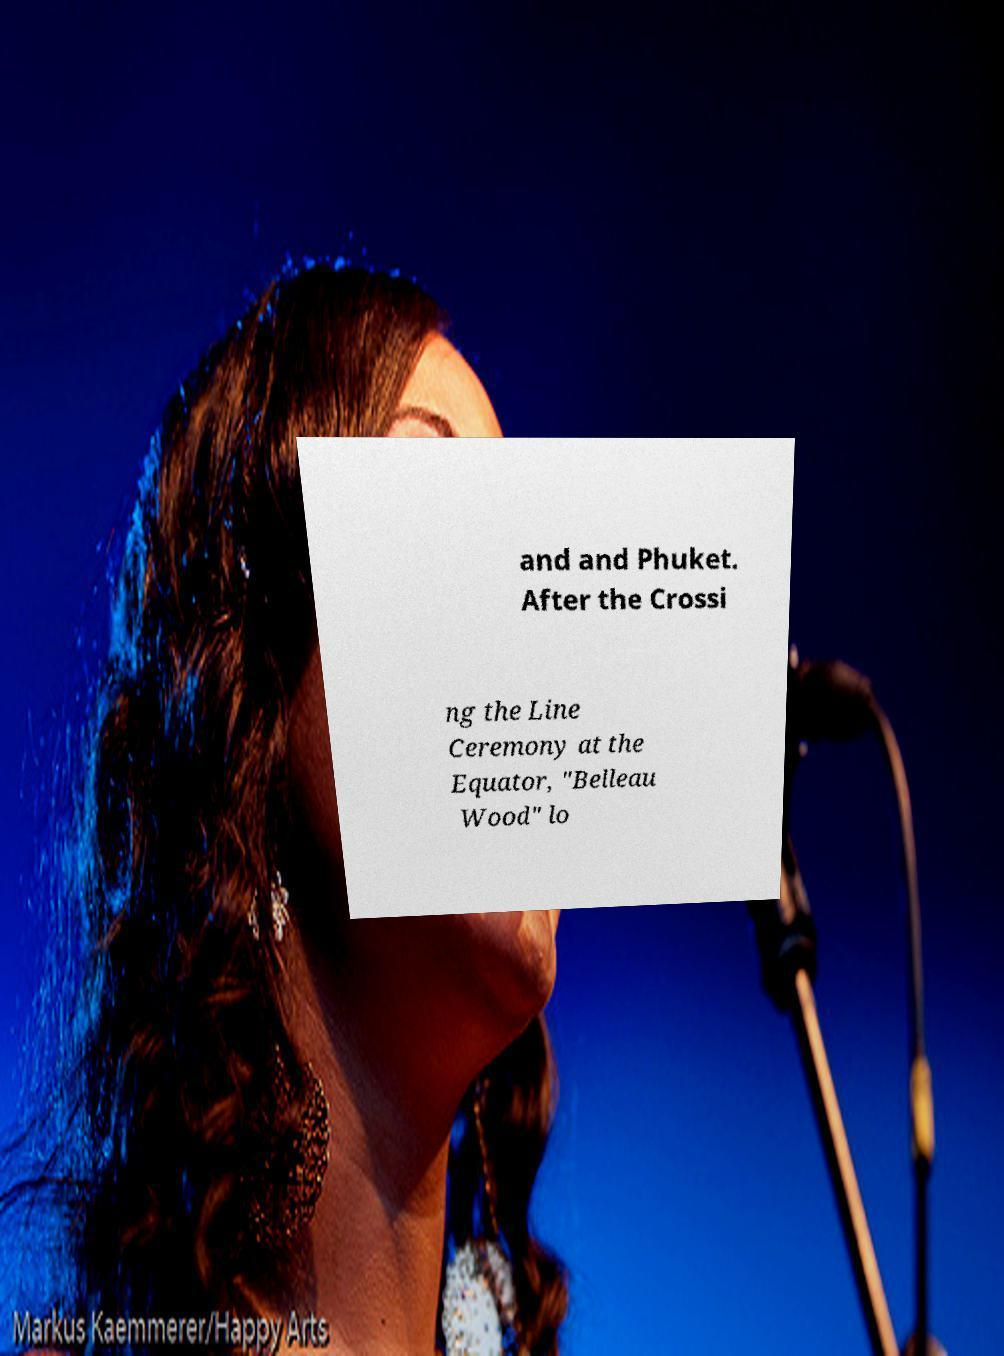Can you accurately transcribe the text from the provided image for me? and and Phuket. After the Crossi ng the Line Ceremony at the Equator, "Belleau Wood" lo 